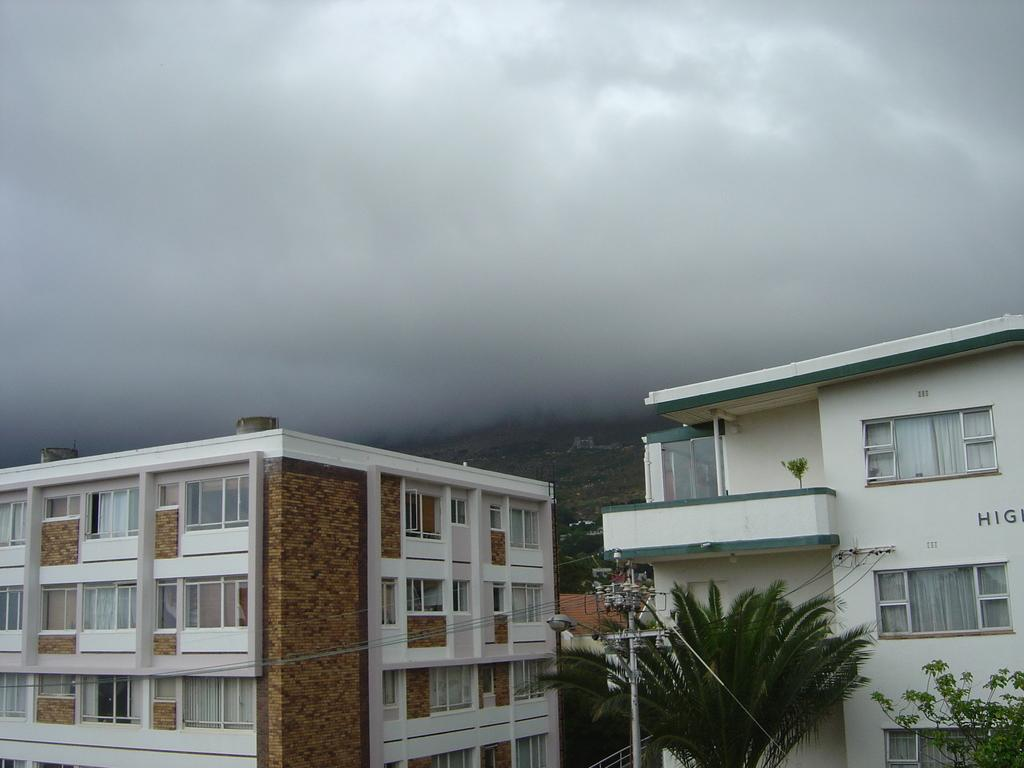What structures are located at the bottom of the image? There are houses, trees, poles, and street lights at the bottom of the image. What type of vegetation is present at the bottom of the image? There are trees at the bottom of the image. What objects are used for illumination at the bottom of the image? There are street lights at the bottom of the image. What can be seen in the background of the image? There are mountains and fog in the background of the image. What type of cheese is being used to make the language barrier visible in the image? There is no cheese or language barrier present in the image. What type of skirt is being worn by the mountain in the background of the image? There is no skirt present in the image, as mountains do not wear clothing. 